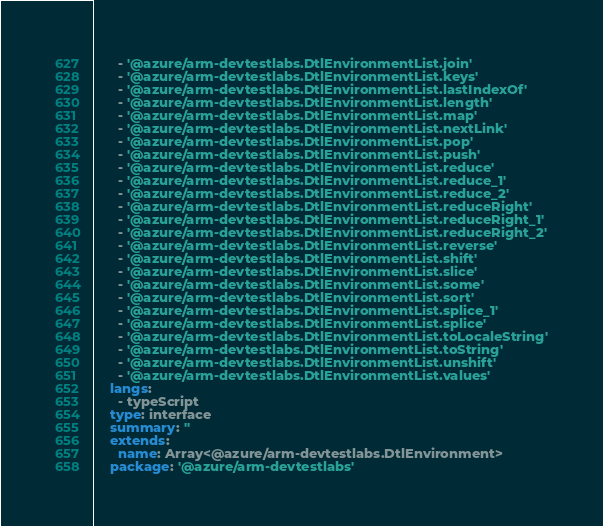Convert code to text. <code><loc_0><loc_0><loc_500><loc_500><_YAML_>      - '@azure/arm-devtestlabs.DtlEnvironmentList.join'
      - '@azure/arm-devtestlabs.DtlEnvironmentList.keys'
      - '@azure/arm-devtestlabs.DtlEnvironmentList.lastIndexOf'
      - '@azure/arm-devtestlabs.DtlEnvironmentList.length'
      - '@azure/arm-devtestlabs.DtlEnvironmentList.map'
      - '@azure/arm-devtestlabs.DtlEnvironmentList.nextLink'
      - '@azure/arm-devtestlabs.DtlEnvironmentList.pop'
      - '@azure/arm-devtestlabs.DtlEnvironmentList.push'
      - '@azure/arm-devtestlabs.DtlEnvironmentList.reduce'
      - '@azure/arm-devtestlabs.DtlEnvironmentList.reduce_1'
      - '@azure/arm-devtestlabs.DtlEnvironmentList.reduce_2'
      - '@azure/arm-devtestlabs.DtlEnvironmentList.reduceRight'
      - '@azure/arm-devtestlabs.DtlEnvironmentList.reduceRight_1'
      - '@azure/arm-devtestlabs.DtlEnvironmentList.reduceRight_2'
      - '@azure/arm-devtestlabs.DtlEnvironmentList.reverse'
      - '@azure/arm-devtestlabs.DtlEnvironmentList.shift'
      - '@azure/arm-devtestlabs.DtlEnvironmentList.slice'
      - '@azure/arm-devtestlabs.DtlEnvironmentList.some'
      - '@azure/arm-devtestlabs.DtlEnvironmentList.sort'
      - '@azure/arm-devtestlabs.DtlEnvironmentList.splice_1'
      - '@azure/arm-devtestlabs.DtlEnvironmentList.splice'
      - '@azure/arm-devtestlabs.DtlEnvironmentList.toLocaleString'
      - '@azure/arm-devtestlabs.DtlEnvironmentList.toString'
      - '@azure/arm-devtestlabs.DtlEnvironmentList.unshift'
      - '@azure/arm-devtestlabs.DtlEnvironmentList.values'
    langs:
      - typeScript
    type: interface
    summary: ''
    extends:
      name: Array<@azure/arm-devtestlabs.DtlEnvironment>
    package: '@azure/arm-devtestlabs'</code> 